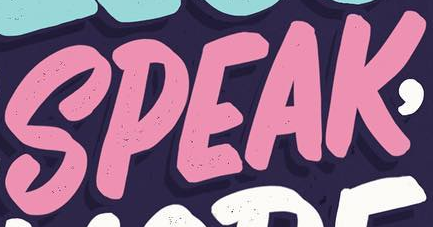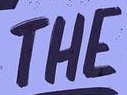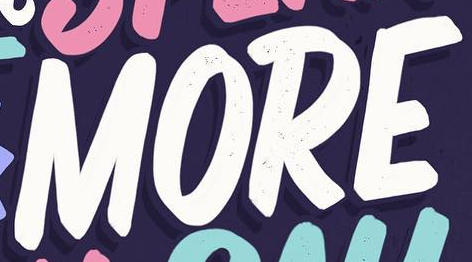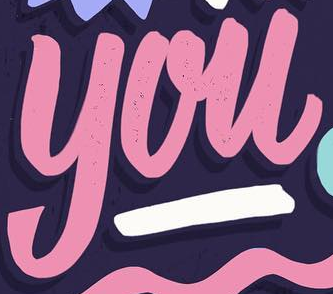Read the text from these images in sequence, separated by a semicolon. SPEAK; THE; MORE; you 